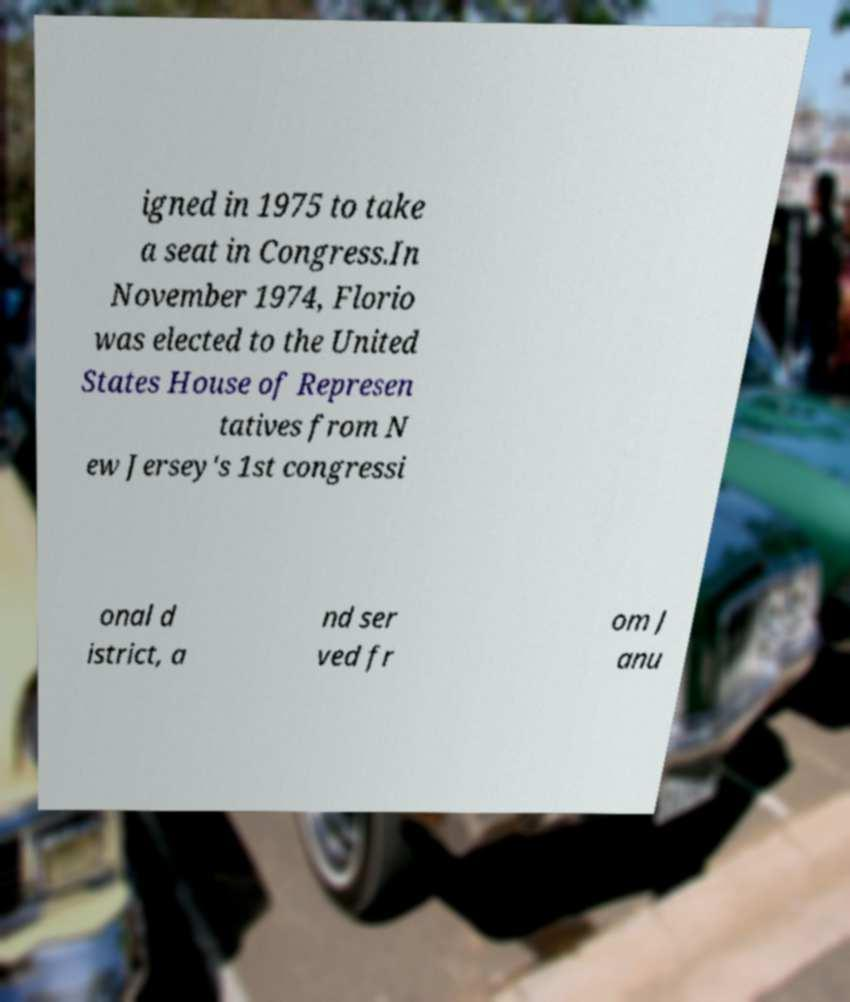For documentation purposes, I need the text within this image transcribed. Could you provide that? igned in 1975 to take a seat in Congress.In November 1974, Florio was elected to the United States House of Represen tatives from N ew Jersey's 1st congressi onal d istrict, a nd ser ved fr om J anu 